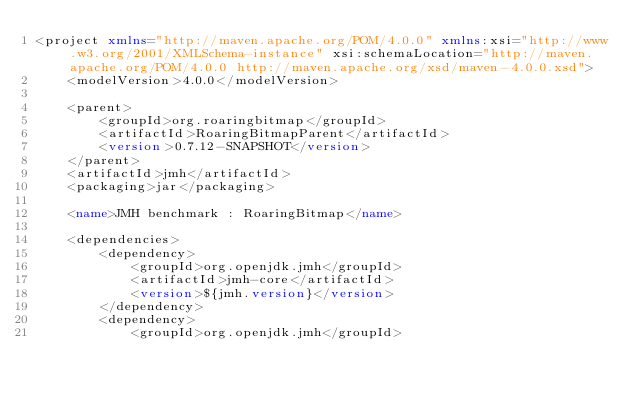<code> <loc_0><loc_0><loc_500><loc_500><_XML_><project xmlns="http://maven.apache.org/POM/4.0.0" xmlns:xsi="http://www.w3.org/2001/XMLSchema-instance" xsi:schemaLocation="http://maven.apache.org/POM/4.0.0 http://maven.apache.org/xsd/maven-4.0.0.xsd">
    <modelVersion>4.0.0</modelVersion>

    <parent>
        <groupId>org.roaringbitmap</groupId>
        <artifactId>RoaringBitmapParent</artifactId>
        <version>0.7.12-SNAPSHOT</version>
    </parent>
    <artifactId>jmh</artifactId>
    <packaging>jar</packaging>

    <name>JMH benchmark : RoaringBitmap</name>

    <dependencies>
        <dependency>
            <groupId>org.openjdk.jmh</groupId>
            <artifactId>jmh-core</artifactId>
            <version>${jmh.version}</version>
        </dependency>
        <dependency>
            <groupId>org.openjdk.jmh</groupId></code> 